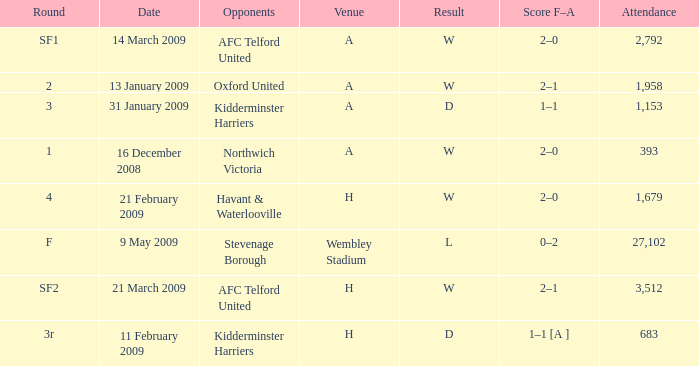What is the round on 21 february 2009? 4.0. 